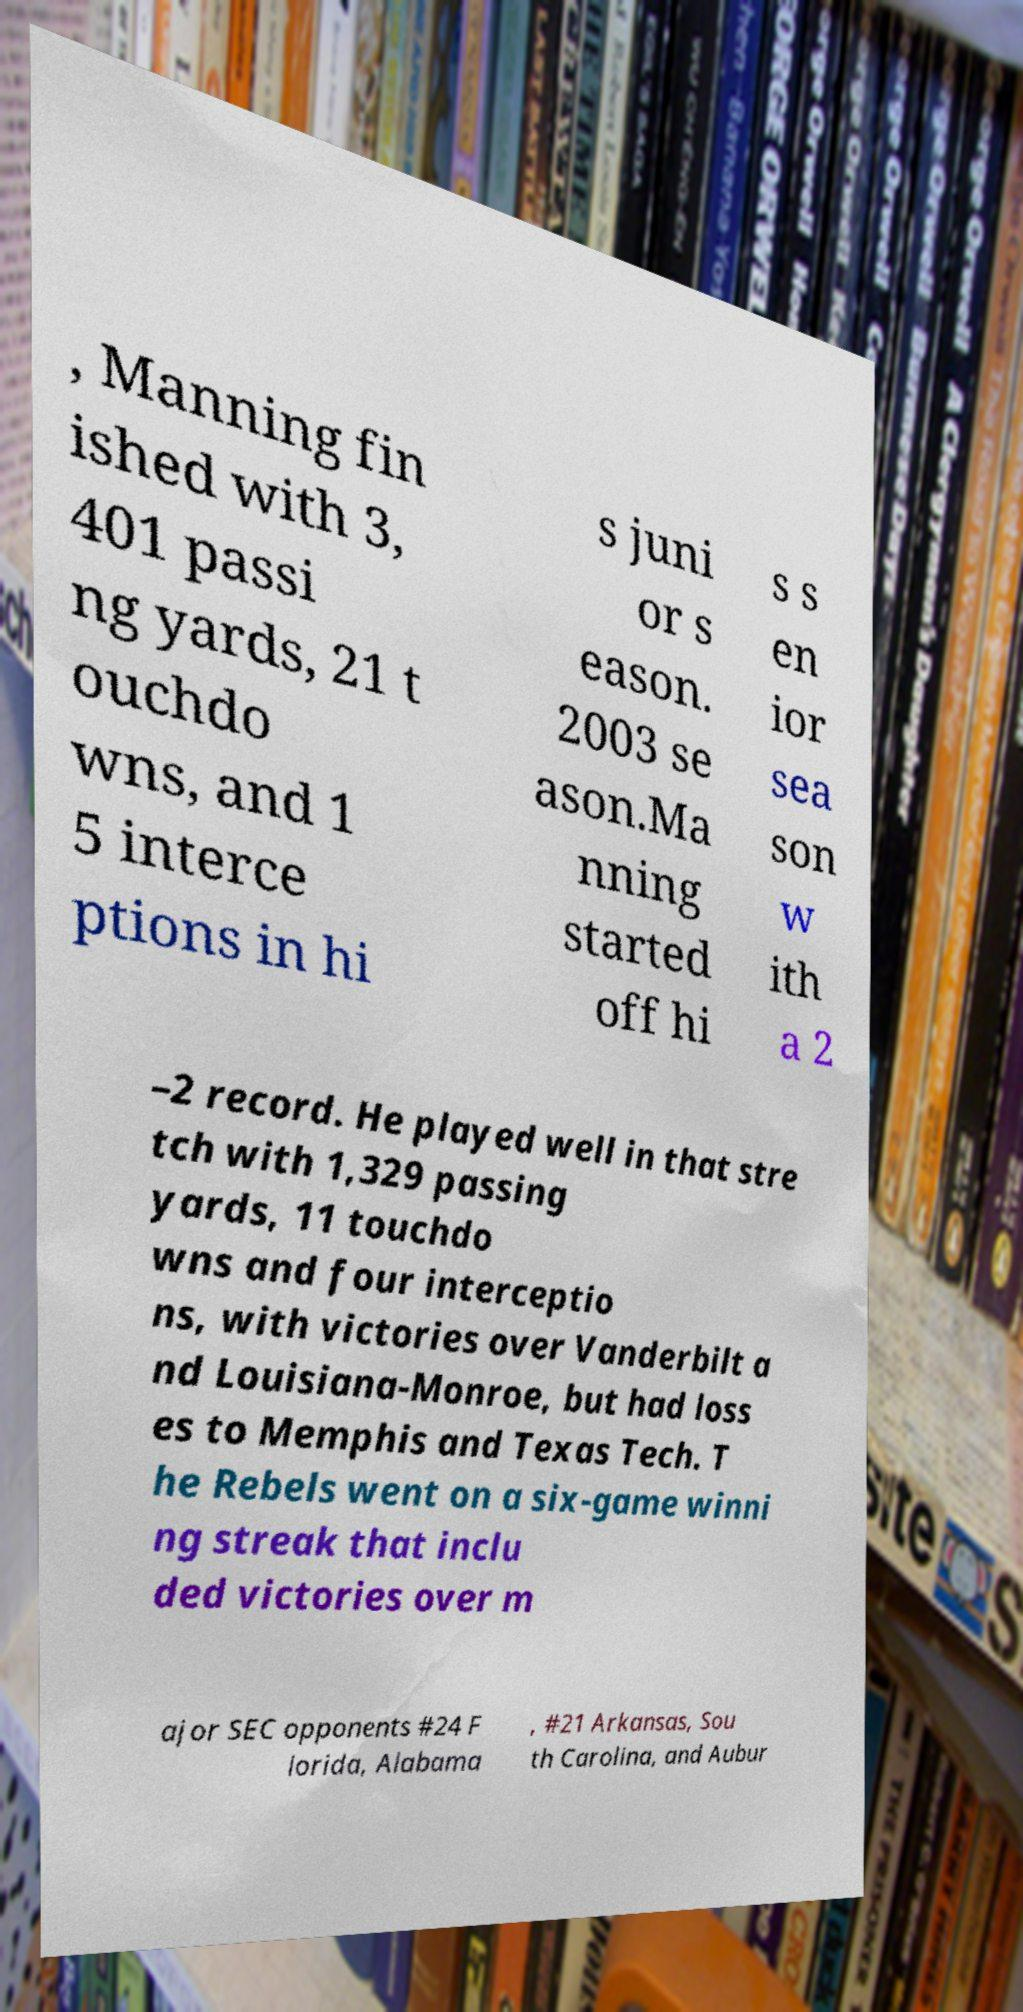Can you read and provide the text displayed in the image?This photo seems to have some interesting text. Can you extract and type it out for me? , Manning fin ished with 3, 401 passi ng yards, 21 t ouchdo wns, and 1 5 interce ptions in hi s juni or s eason. 2003 se ason.Ma nning started off hi s s en ior sea son w ith a 2 –2 record. He played well in that stre tch with 1,329 passing yards, 11 touchdo wns and four interceptio ns, with victories over Vanderbilt a nd Louisiana-Monroe, but had loss es to Memphis and Texas Tech. T he Rebels went on a six-game winni ng streak that inclu ded victories over m ajor SEC opponents #24 F lorida, Alabama , #21 Arkansas, Sou th Carolina, and Aubur 